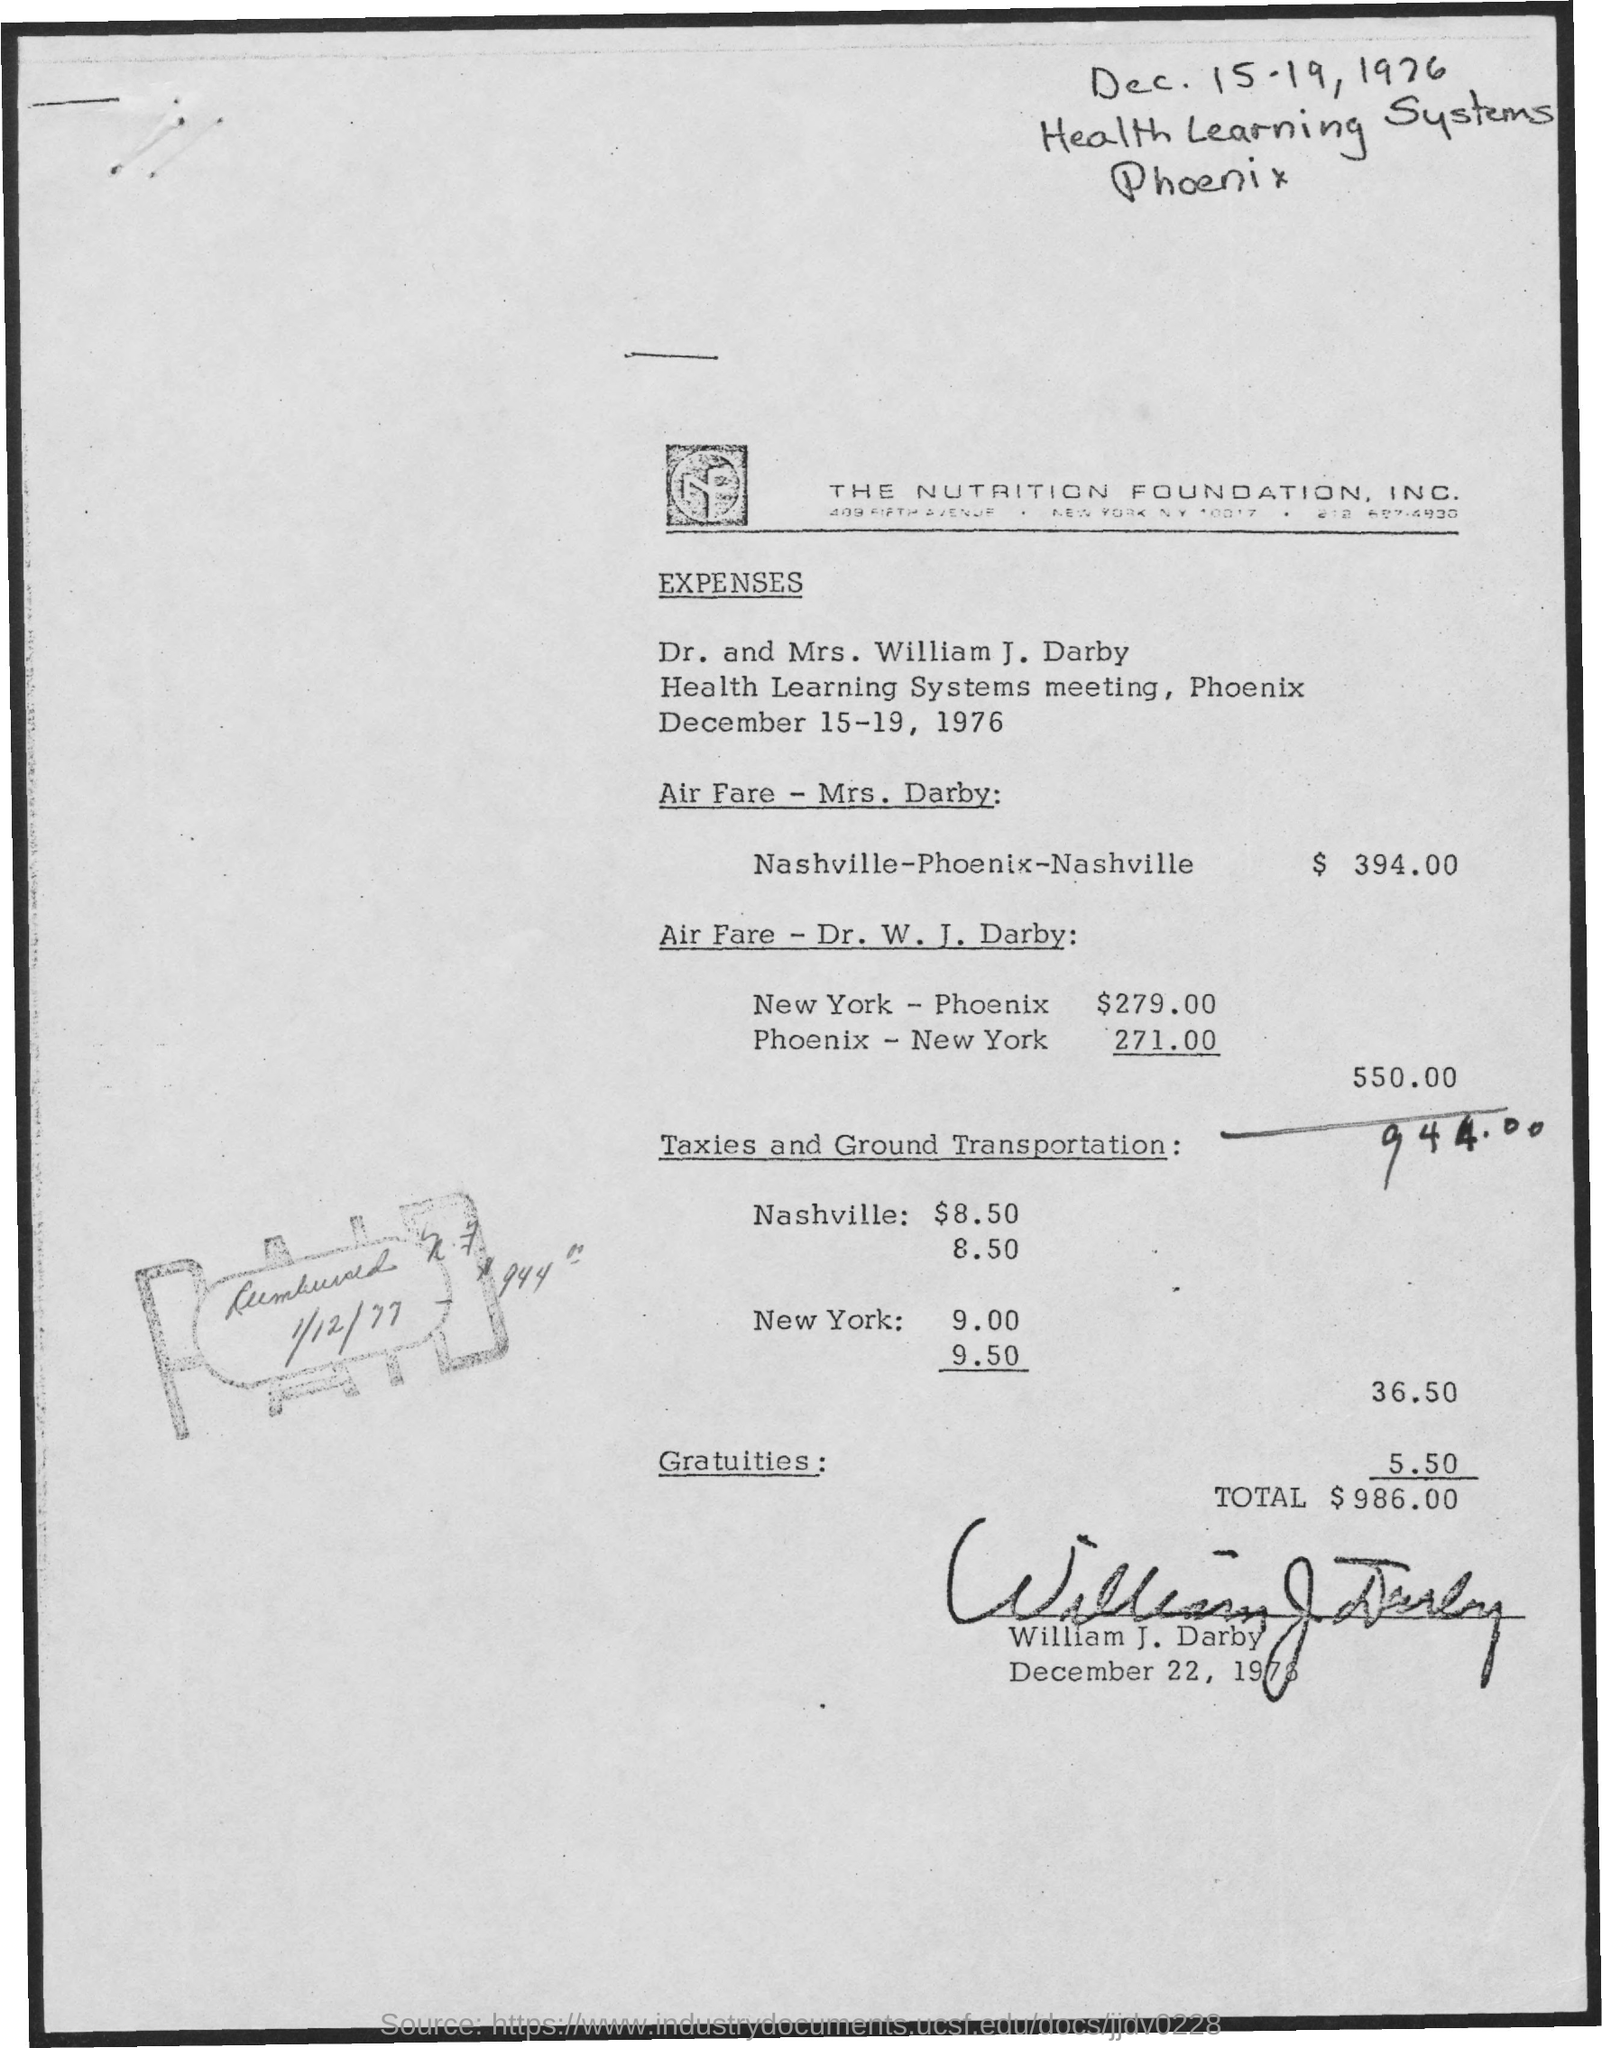Highlight a few significant elements in this photo. The total amount for airfare for Dr. W. J. Darby is $550.00. The total amount of expenses is $986.00. Nutrition Foundation" is an abbreviation that stands for a specific organization or concept related to nutrition and food. The total amount of taxies and ground transportation is 36.50. The amount of gratuities is 5.50. 